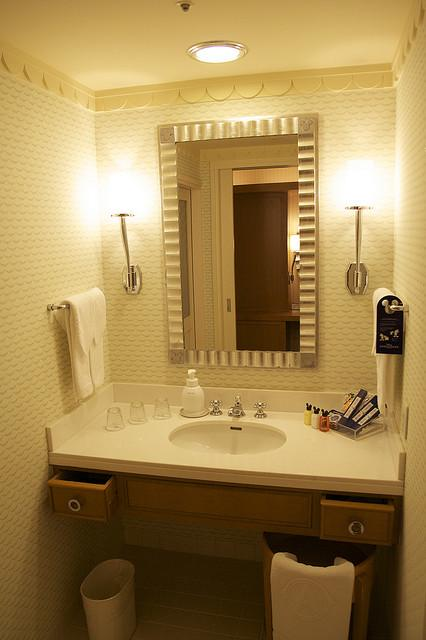Who provides the bottles on the counter? hotel 